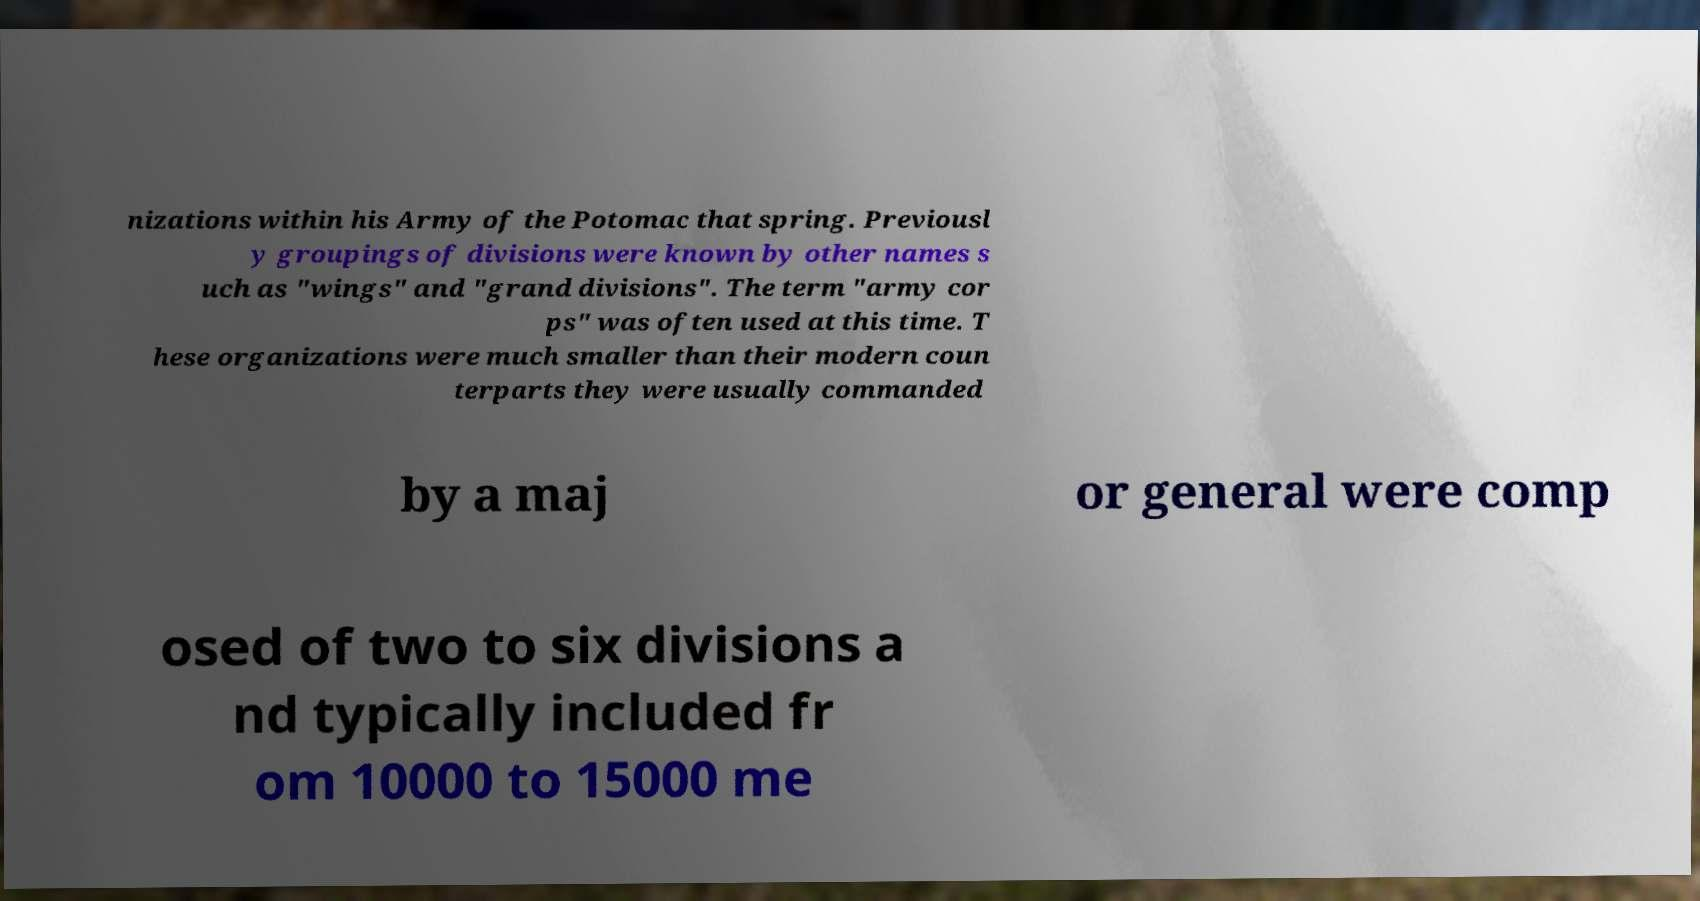There's text embedded in this image that I need extracted. Can you transcribe it verbatim? nizations within his Army of the Potomac that spring. Previousl y groupings of divisions were known by other names s uch as "wings" and "grand divisions". The term "army cor ps" was often used at this time. T hese organizations were much smaller than their modern coun terparts they were usually commanded by a maj or general were comp osed of two to six divisions a nd typically included fr om 10000 to 15000 me 